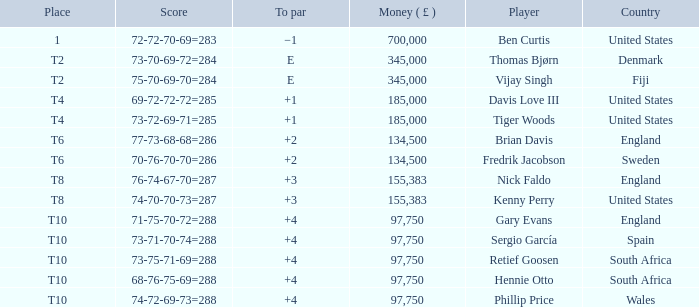What is the Place of Davis Love III with a To Par of +1? T4. 